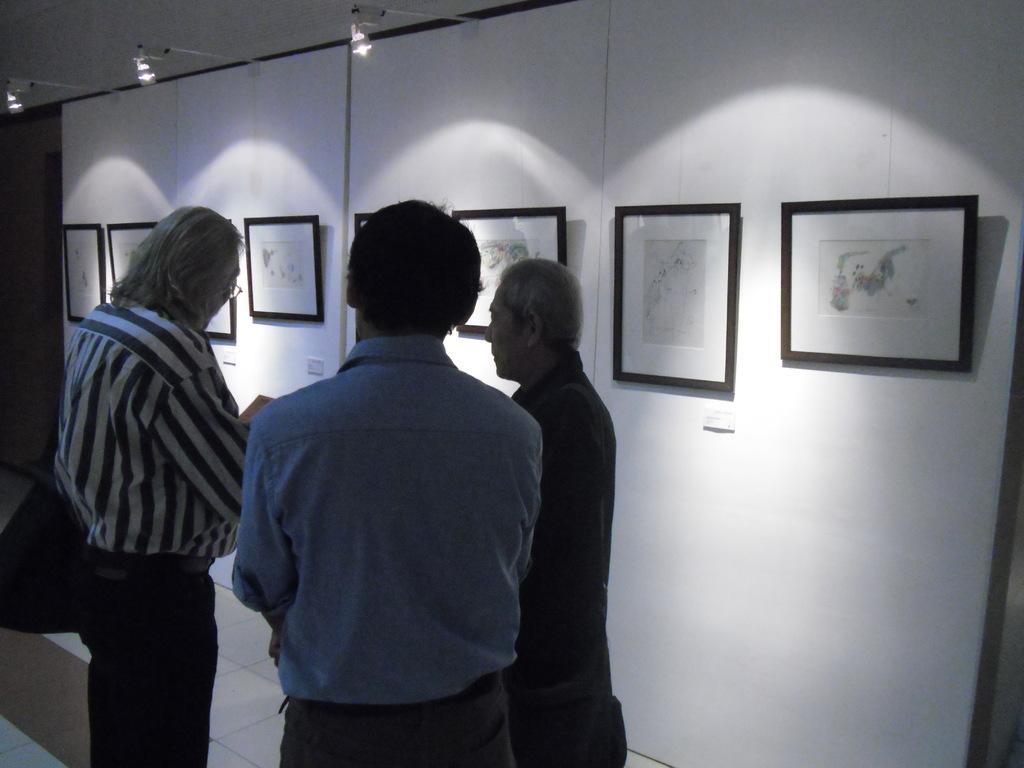Can you describe this image briefly? In front of the picture, we see three men are standing. The man on the left side is wearing a black bag. Beside them, we see a white wall on which photo frames are placed. At the top, we see the lights and the ceiling of the room. On the left side, we see the door. 